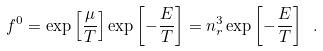<formula> <loc_0><loc_0><loc_500><loc_500>f ^ { 0 } = \exp { \left [ \frac { \mu } { T } \right ] } \exp { \left [ - \frac { E } { T } \right ] } = n _ { r } ^ { 3 } \exp { \left [ - \frac { E } { T } \right ] } \ .</formula> 